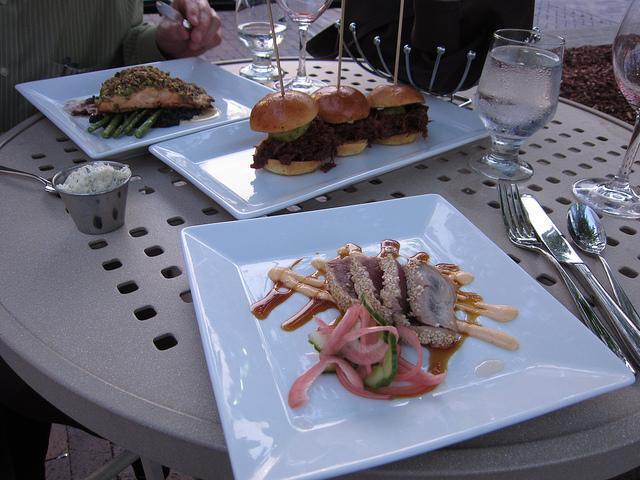How many sandwiches are there?
Give a very brief answer. 4. How many wine glasses are visible?
Give a very brief answer. 3. 